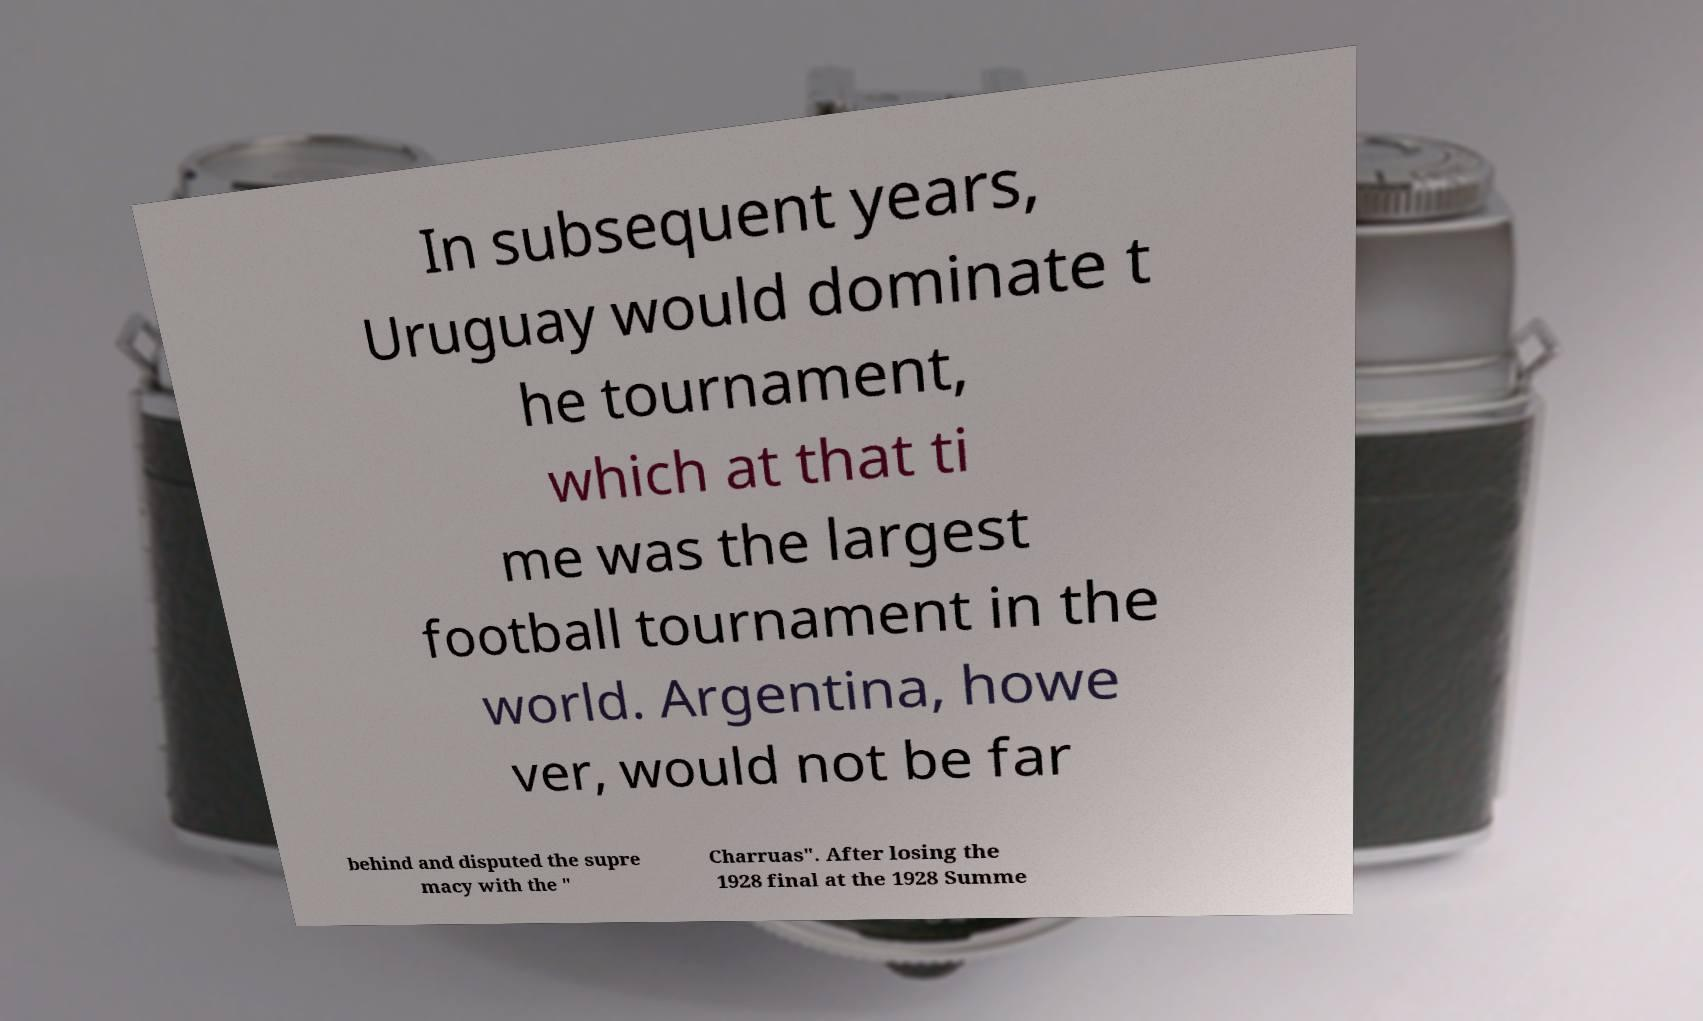Could you extract and type out the text from this image? In subsequent years, Uruguay would dominate t he tournament, which at that ti me was the largest football tournament in the world. Argentina, howe ver, would not be far behind and disputed the supre macy with the " Charruas". After losing the 1928 final at the 1928 Summe 